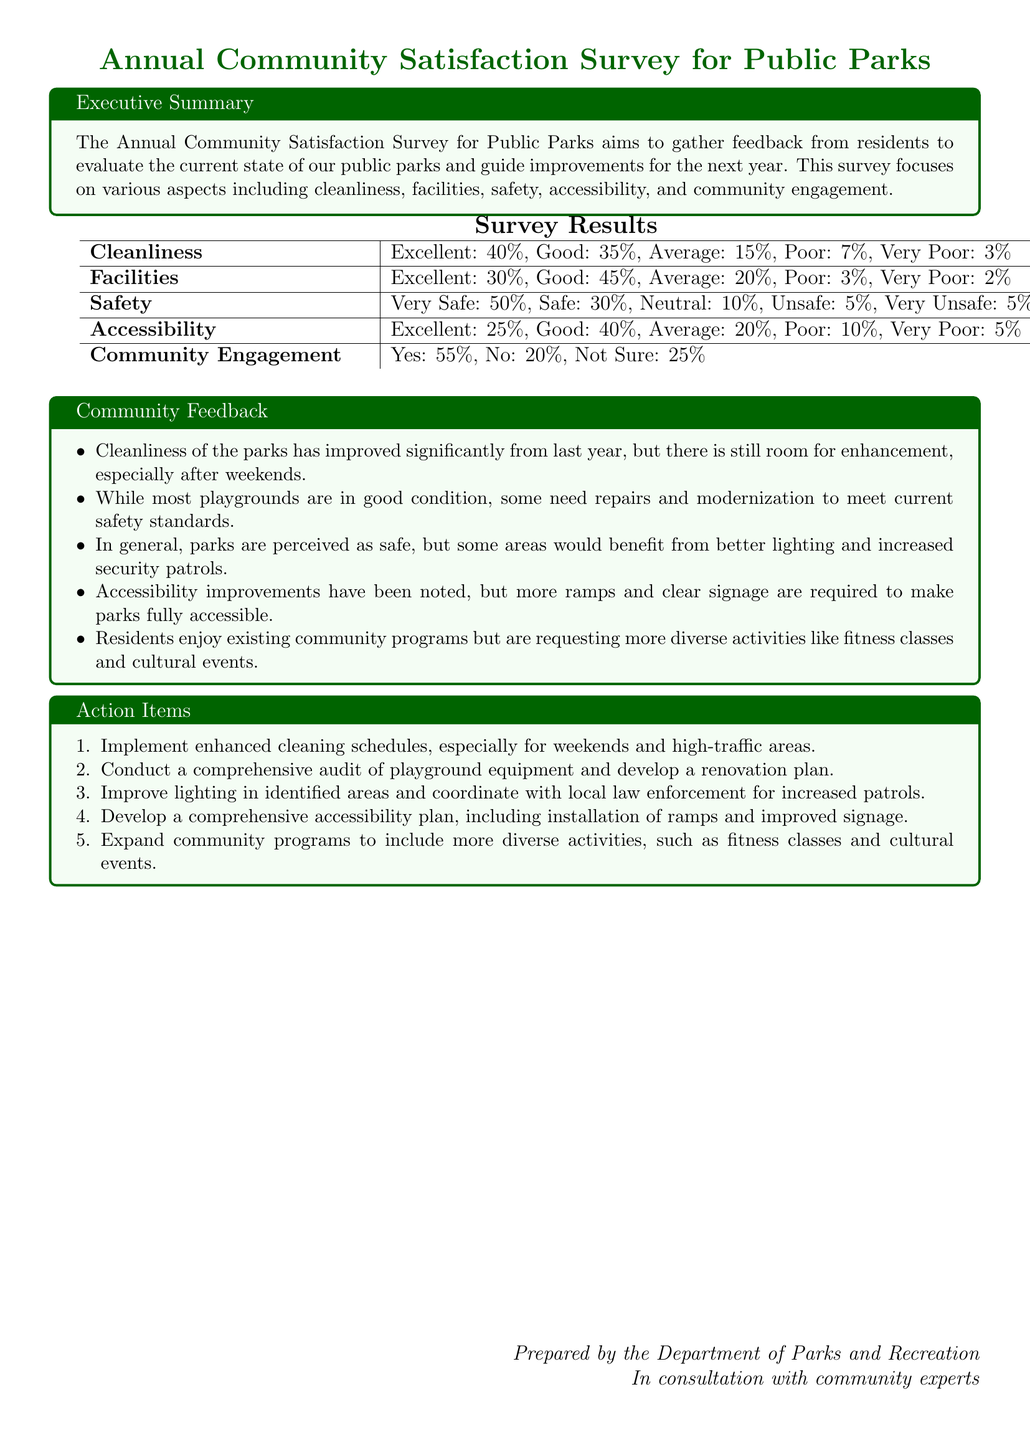What percentage of respondents rated cleanliness as excellent? The document states that 40% of respondents rated cleanliness as excellent.
Answer: 40% What was the percentage of respondents who reported feeling very safe in the parks? According to the survey results, 50% of respondents felt very safe in the parks.
Answer: 50% What action item is proposed for improving community programs? The document suggests expanding community programs to include more diverse activities.
Answer: More diverse activities What percentage of respondents rated accessibility as poor? The document indicates that 10% of respondents rated accessibility as poor.
Answer: 10% What feedback was given regarding playground conditions? The feedback mentioned some playgrounds need repairs and modernization to meet safety standards.
Answer: Repairs and modernization How many respondents were unsure about community engagement? The document states that 25% of respondents were not sure about community engagement.
Answer: 25% What improvement is suggested for lighting in parks? It is suggested to improve lighting in identified areas and coordinate with local law enforcement for increased patrols.
Answer: Improve lighting What is the general perception of safety in the parks? The survey results indicate that parks are generally perceived as safe.
Answer: Generally safe What was noted about the cleanliness of parks compared to last year? The feedback indicates that cleanliness has improved significantly from last year.
Answer: Improved significantly 